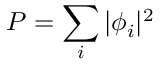<formula> <loc_0><loc_0><loc_500><loc_500>P = \sum _ { i } | \phi _ { i } | ^ { 2 }</formula> 